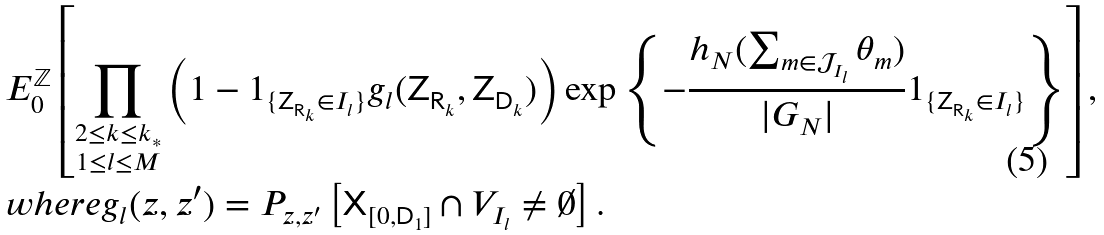Convert formula to latex. <formula><loc_0><loc_0><loc_500><loc_500>& E ^ { \mathbb { Z } } _ { 0 } \left [ \prod _ { \substack { 2 \leq k \leq k _ { * } \\ 1 \leq l \leq M } } \left ( 1 - 1 _ { \{ { \mathsf Z } _ { { \mathsf R } _ { k } } \in I _ { l } \} } g _ { l } ( { \mathsf Z } _ { { \mathsf R } _ { k } } , { \mathsf Z } _ { { \mathsf D } _ { k } } ) \right ) \exp \left \{ - \frac { h _ { N } ( \sum _ { m \in { \mathcal { J } } _ { I _ { l } } } \theta _ { m } ) } { | G _ { N } | } 1 _ { \{ { \mathsf Z } _ { { \mathsf R } _ { k } } \in I _ { l } \} } \right \} \right ] , \\ & w h e r e g _ { l } ( z , z ^ { \prime } ) = P _ { z , z ^ { \prime } } \left [ { \mathsf X } _ { [ 0 , { \mathsf D } _ { 1 } ] } \cap V _ { I _ { l } } \neq \emptyset \right ] .</formula> 